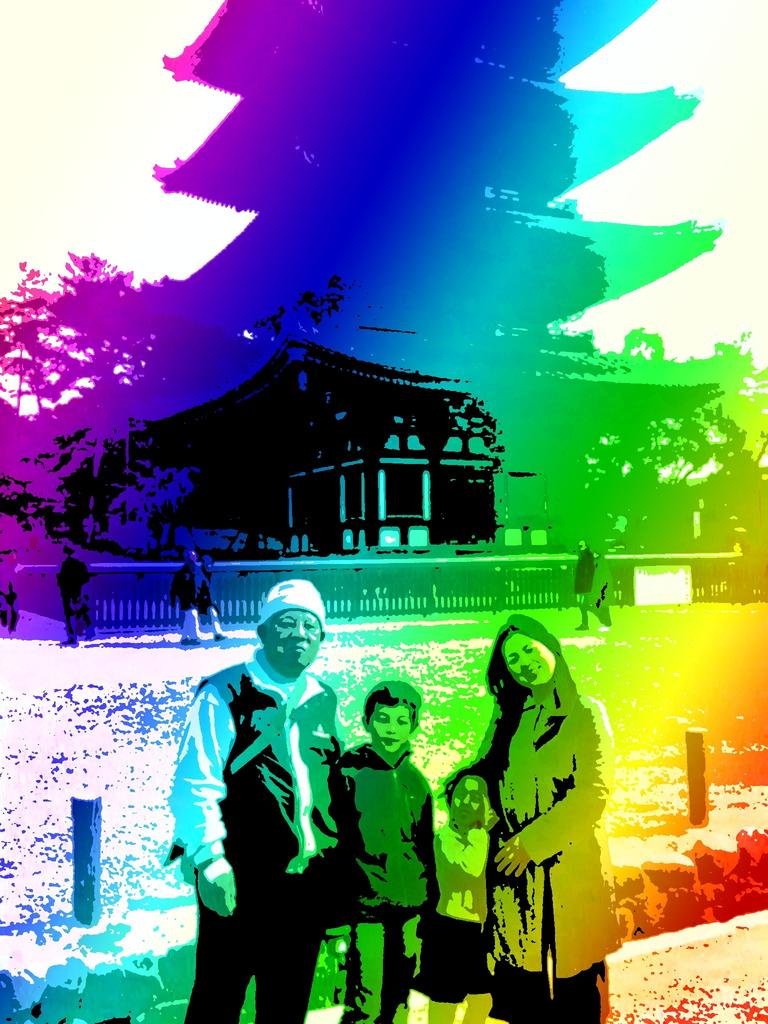What can be observed about the image itself? The image appears to be edited. How many people are standing at the bottom of the image? There are four persons standing at the bottom of the image. What can be seen in the background of the image? There is a house visible in the background. What type of vegetation is on the left side of the image? There are trees on the left side of the image. How many seats are available for the giants in the image? There are no giants present in the image, and therefore no seats are required for them. 